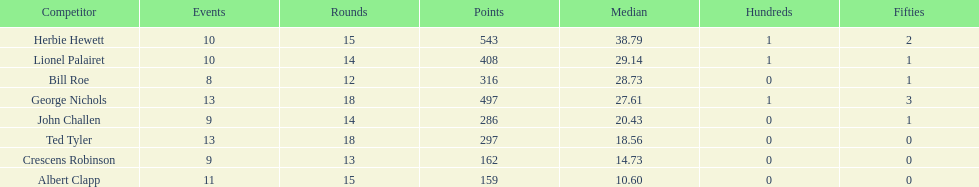What were the number of innings albert clapp had? 15. 